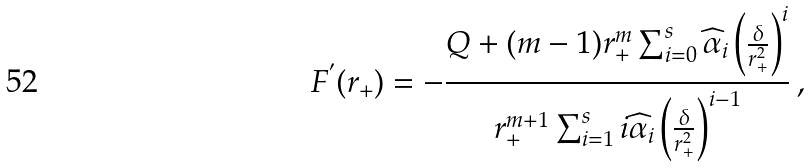Convert formula to latex. <formula><loc_0><loc_0><loc_500><loc_500>F ^ { ^ { \prime } } ( r _ { + } ) = - \frac { Q + ( m - 1 ) r _ { + } ^ { m } \sum _ { i = 0 } ^ { s } \widehat { \alpha } _ { i } \left ( \frac { \delta } { r _ { + } ^ { 2 } } \right ) ^ { i } } { r _ { + } ^ { m + 1 } \sum _ { i = 1 } ^ { s } i \widehat { \alpha } _ { i } \left ( \frac { \delta } { r _ { + } ^ { 2 } } \right ) ^ { i - 1 } } \, ,</formula> 